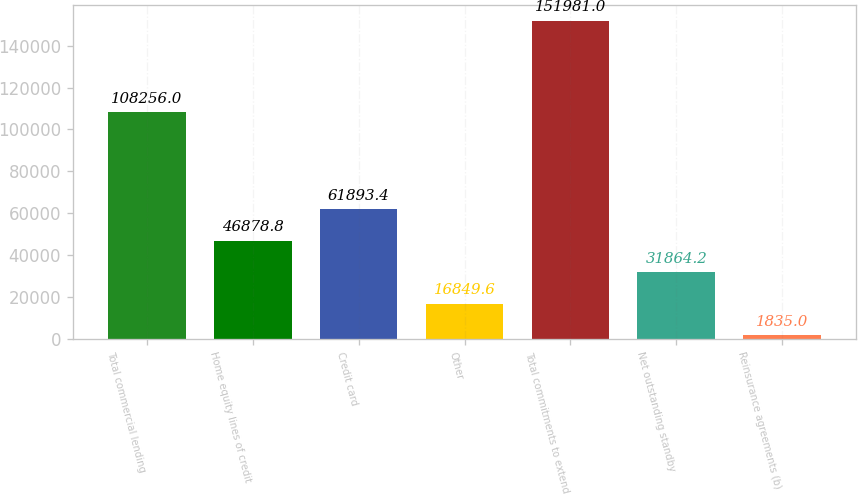Convert chart. <chart><loc_0><loc_0><loc_500><loc_500><bar_chart><fcel>Total commercial lending<fcel>Home equity lines of credit<fcel>Credit card<fcel>Other<fcel>Total commitments to extend<fcel>Net outstanding standby<fcel>Reinsurance agreements (b)<nl><fcel>108256<fcel>46878.8<fcel>61893.4<fcel>16849.6<fcel>151981<fcel>31864.2<fcel>1835<nl></chart> 